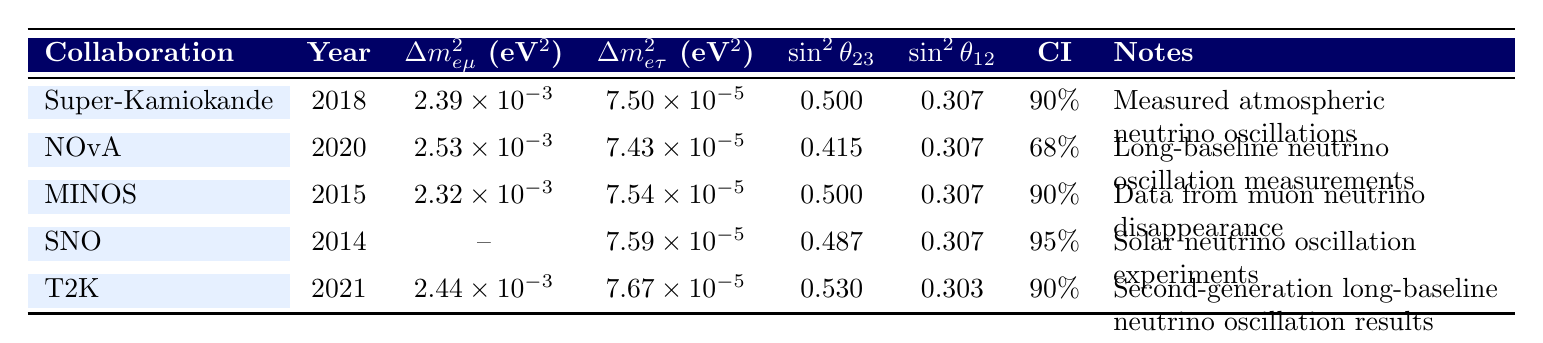What is the value of δm²ₑₘₐ from the NOvA collaboration? The table displays a specific measurement for NOvA in the δm²ₑₘₐ column, which is listed as 2.53e-3.
Answer: 2.53e-3 What is the confidence interval (CI) reported by SNO? The CI for SNO, as shown in the table, is marked as 95%.
Answer: 95% Which collaboration reported a measurement in 2018? According to the table, Super-Kamiokande is the collaboration that provided measurements in the year 2018.
Answer: Super-Kamiokande Is there any collaboration that provided results for δm²ₑₜₐ? The table indicates that both SNO and the other collaborations have provided results for δm²ₑₜₐ. For SNO, it is specifically listed as 7.59e-5.
Answer: Yes What is the average value of sin²θ₂₃ from the collaborations presented? The values of sin²θ₂₃ from the table are 0.500 (Super-Kamiokande), 0.415 (NOvA), 0.500 (MINOS), 0.487 (SNO), and 0.530 (T2K). Adding these values results in a sum of 2.432. Dividing this by the number of collaborations (5) gives an average of 2.432/5 = 0.4864.
Answer: 0.4864 Does the collaboration MINOS have a δm²ₑₓₓ measurement listed? The table shows that MINOS provided a measurement for δm²ₑₐ, but there is no entry for δm²ₑₓₓ, which means the specific measurement is not applicable.
Answer: No Which collaboration has the lowest value for sin²θ₁₂? The table indicates that T2K has the lowest value for sin²θ₁₂ at 0.303, while others are at 0.307 or higher.
Answer: T2K If we compare the measurements of δm²ₑₘₐ for Super-Kamiokande and T2K, which one is higher? The values from the two collaborations are 2.39e-3 for Super-Kamiokande and 2.44e-3 for T2K. Comparing these, T2K has the higher value.
Answer: T2K Which collaboration reports the highest value for sin²θ₂₃? Among the listed collaborations, T2K reports the highest sin²θ₂₃ value of 0.530 compared to the others.
Answer: T2K 